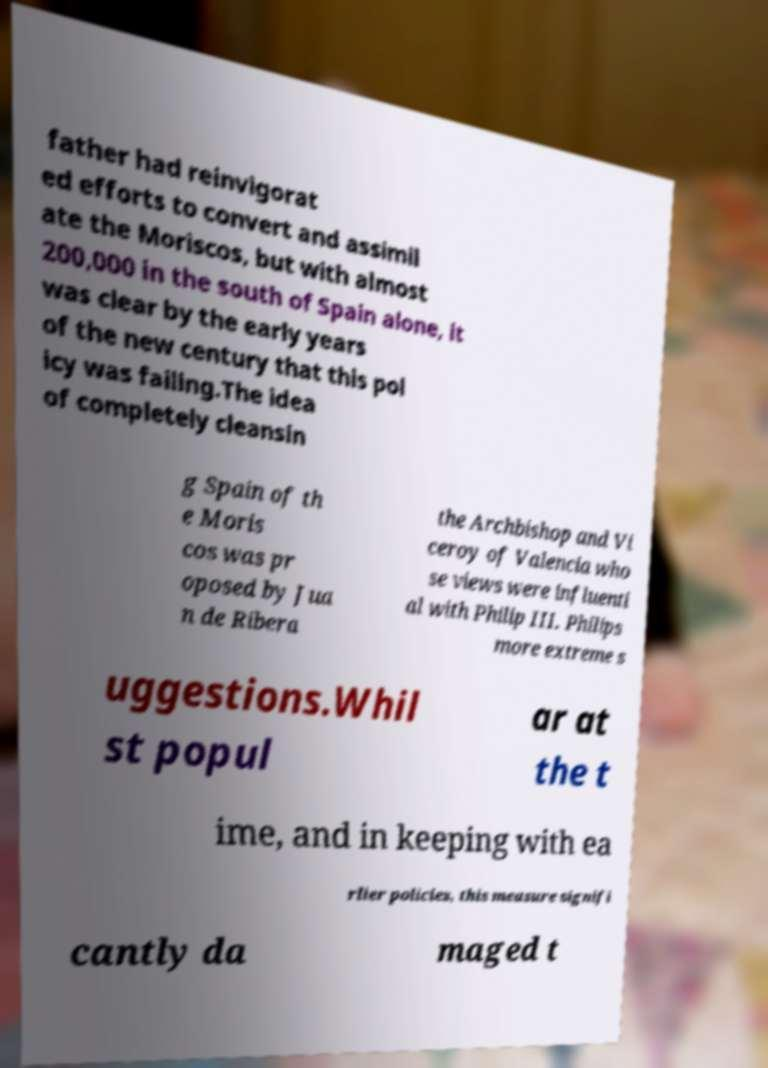What messages or text are displayed in this image? I need them in a readable, typed format. father had reinvigorat ed efforts to convert and assimil ate the Moriscos, but with almost 200,000 in the south of Spain alone, it was clear by the early years of the new century that this pol icy was failing.The idea of completely cleansin g Spain of th e Moris cos was pr oposed by Jua n de Ribera the Archbishop and Vi ceroy of Valencia who se views were influenti al with Philip III. Philips more extreme s uggestions.Whil st popul ar at the t ime, and in keeping with ea rlier policies, this measure signifi cantly da maged t 